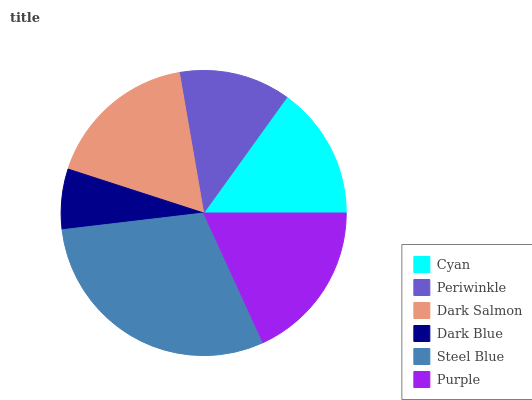Is Dark Blue the minimum?
Answer yes or no. Yes. Is Steel Blue the maximum?
Answer yes or no. Yes. Is Periwinkle the minimum?
Answer yes or no. No. Is Periwinkle the maximum?
Answer yes or no. No. Is Cyan greater than Periwinkle?
Answer yes or no. Yes. Is Periwinkle less than Cyan?
Answer yes or no. Yes. Is Periwinkle greater than Cyan?
Answer yes or no. No. Is Cyan less than Periwinkle?
Answer yes or no. No. Is Dark Salmon the high median?
Answer yes or no. Yes. Is Cyan the low median?
Answer yes or no. Yes. Is Purple the high median?
Answer yes or no. No. Is Steel Blue the low median?
Answer yes or no. No. 